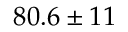<formula> <loc_0><loc_0><loc_500><loc_500>8 0 . 6 \pm 1 1</formula> 